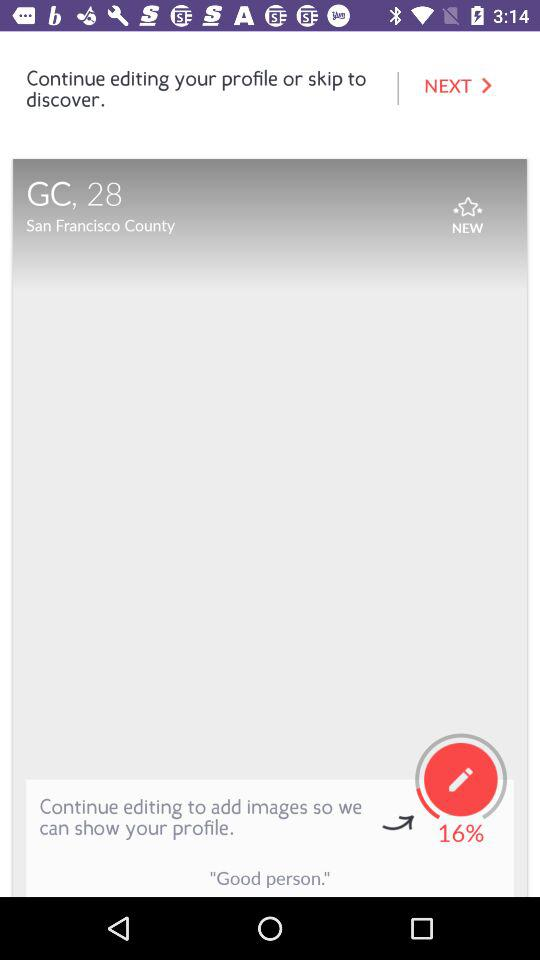What is the mentioned location? The mentioned location is San Francisco County. 